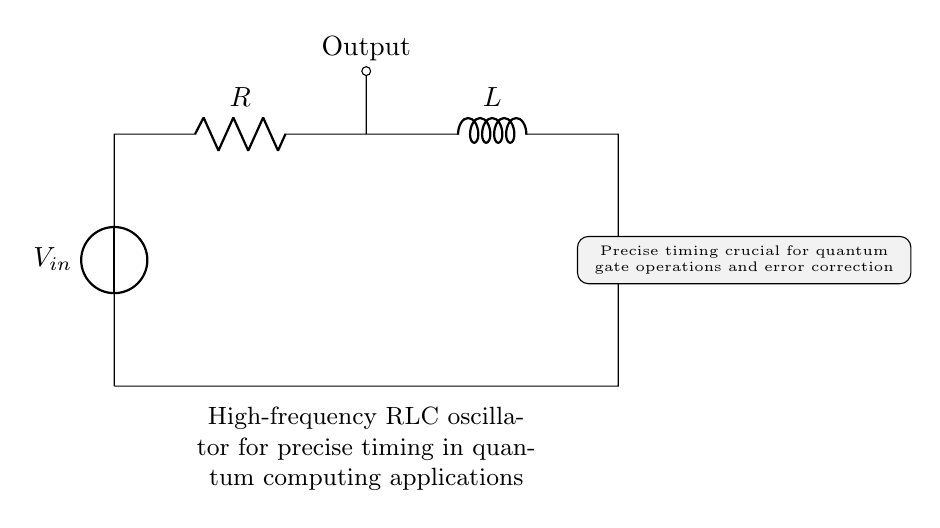What components are in the circuit? The circuit contains a voltage source, a resistor, an inductor, and a capacitor, which are labeled in the diagram.
Answer: voltage source, resistor, inductor, capacitor What is the purpose of the oscillation in this circuit? The oscillation in this RLC circuit generates high-frequency signals that are essential for precise timing in quantum computing applications.
Answer: precise timing What does the output represent? The output in the circuit is the point where the oscillating signal is available for use in timing applications. It is located at the junction after the resistor.
Answer: Output How do R, L, and C relate to the frequency of oscillation? The resonant frequency of the RLC circuit is determined by the values of the resistor, inductor, and capacitor, where lower resistance and appropriate L and C values lead to higher frequencies.
Answer: frequency What is the role of the resistor in this circuit? The resistor is responsible for controlling the energy dissipation in the circuit, which affects the quality factor and damping of the oscillation.
Answer: energy dissipation What type of circuit is this considered? This circuit is considered a resonant or oscillatory circuit, specifically an RLC oscillator, as it combines resistance, inductance, and capacitance to produce oscillations.
Answer: RLC oscillator 